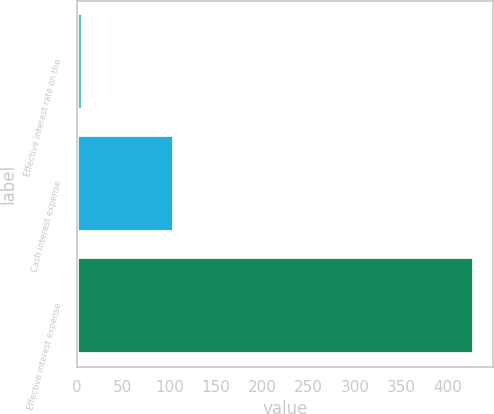Convert chart to OTSL. <chart><loc_0><loc_0><loc_500><loc_500><bar_chart><fcel>Effective interest rate on the<fcel>Cash interest expense<fcel>Effective interest expense<nl><fcel>6.86<fcel>105<fcel>428<nl></chart> 